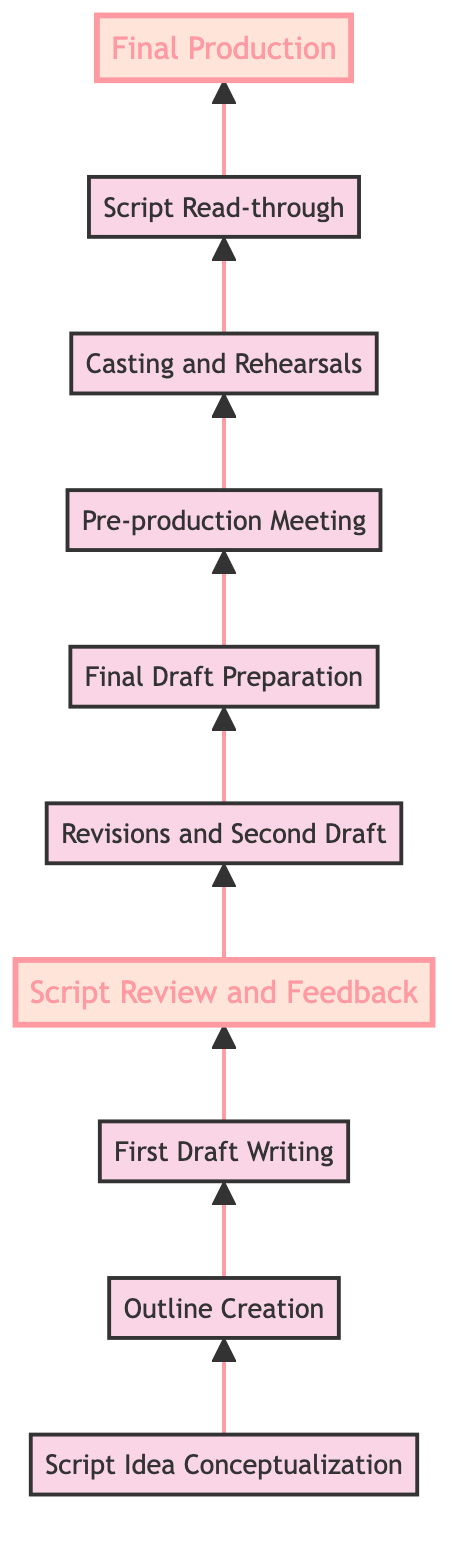What is the first step in the script development process? The first step is "Script Idea Conceptualization" as it is the bottom node from which the process starts.
Answer: Script Idea Conceptualization How many nodes are there in this flow chart? Counting all the distinct steps provided, there are ten nodes in total in the diagram.
Answer: Ten What follows "Script Review and Feedback"? According to the diagram, "Revisions and Second Draft" directly follows "Script Review and Feedback".
Answer: Revisions and Second Draft Which step is highlighted, indicating its importance? The highlighted nodes are "Script Review and Feedback" and "Final Production", signifying their significance in the process.
Answer: Script Review and Feedback, Final Production What is the final step in the process? The last node in the flow chart represents the end of the process, which is "Final Production".
Answer: Final Production What are the two steps that come before "Final Draft Preparation"? The two preceding steps are "Revisions and Second Draft" followed by "Script Review and Feedback", indicating a cycle of critique and rewrite.
Answer: Revisions and Second Draft, Script Review and Feedback In what order do the steps lead to the final production? The order leading to final production is: Script Idea Conceptualization, Outline Creation, First Draft Writing, Script Review and Feedback, Revisions and Second Draft, Final Draft Preparation, Pre-production Meeting, Casting and Rehearsals, Script Read-through, Final Production.
Answer: Script Idea Conceptualization, Outline Creation, First Draft Writing, Script Review and Feedback, Revisions and Second Draft, Final Draft Preparation, Pre-production Meeting, Casting and Rehearsals, Script Read-through, Final Production Which step involves critiques from colleagues or mentors? "Script Review and Feedback" is the step where critiques and suggestions are received from colleagues, producers, or mentors.
Answer: Script Review and Feedback What type of meeting occurs after "Final Draft Preparation"? The meeting that occurs next is a "Pre-production Meeting", where logistics and resources are discussed based on the final script.
Answer: Pre-production Meeting 